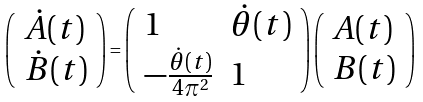Convert formula to latex. <formula><loc_0><loc_0><loc_500><loc_500>\left ( \begin{array} { l l } \dot { A } ( t ) \\ \dot { B } ( t ) \end{array} \right ) = \left ( \begin{array} { l l } 1 & \dot { \theta } ( t ) \\ - \frac { \dot { \theta } ( t ) } { 4 \pi ^ { 2 } } & 1 \end{array} \right ) \left ( \begin{array} { l l } A ( t ) \\ B ( t ) \end{array} \right )</formula> 